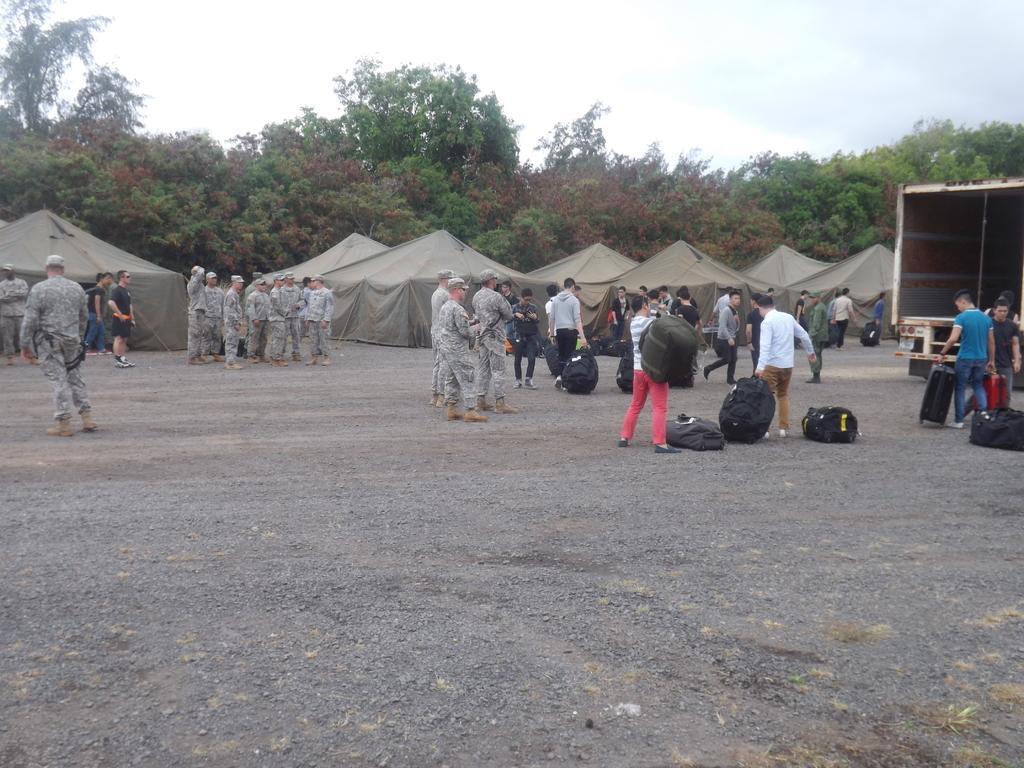Could you give a brief overview of what you see in this image? In this image I can see the group of people with different color dresses and few people with military uniforms. I can see few people are holding the bags and few bags are on the ground. In the background I can see the vehicle, tents, many trees and the sky. 